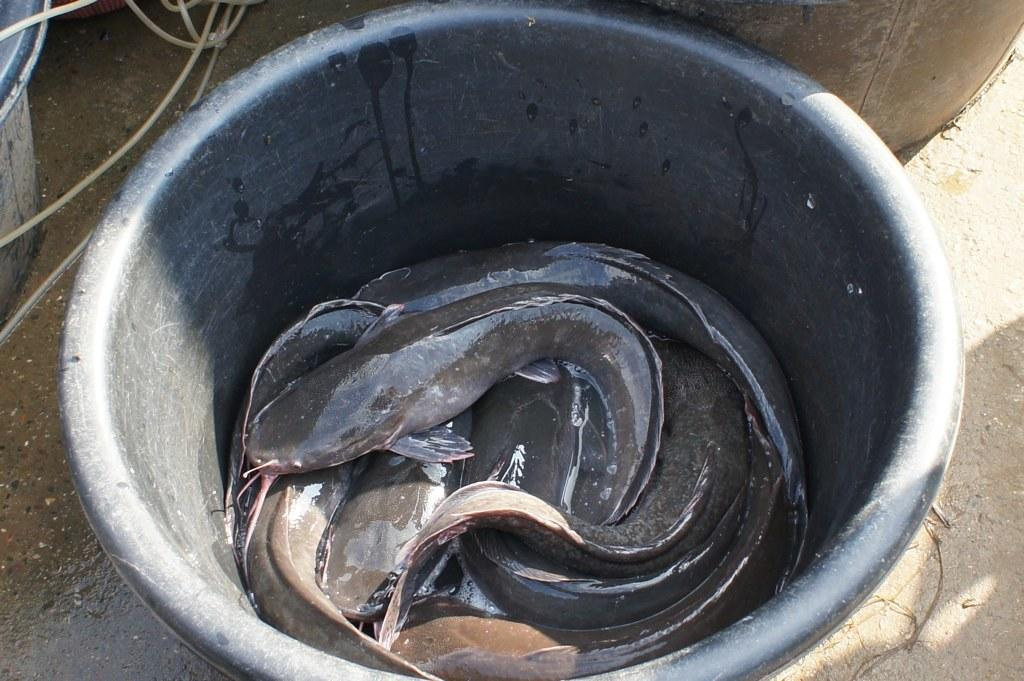What type of animals can be seen in the image? There are fishes in a black color tub in the image. What part of the image is visible at the bottom? The floor is visible at the bottom of the image. Where are the wires located in the image? The wires are on the left side of the image. What type of notebook is being used by the chin in the image? There is no notebook or chin present in the image. What type of kettle is visible on the right side of the image? There is no kettle visible in the image; only fishes, a black color tub, the floor, and wires are present. 